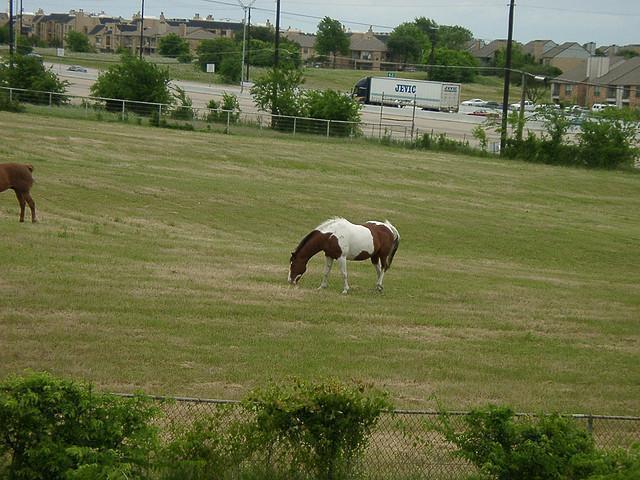What type of animals are present?
Select the correct answer and articulate reasoning with the following format: 'Answer: answer
Rationale: rationale.'
Options: Deer, dog, horse, giraffe. Answer: horse.
Rationale: Horses are in the field. 